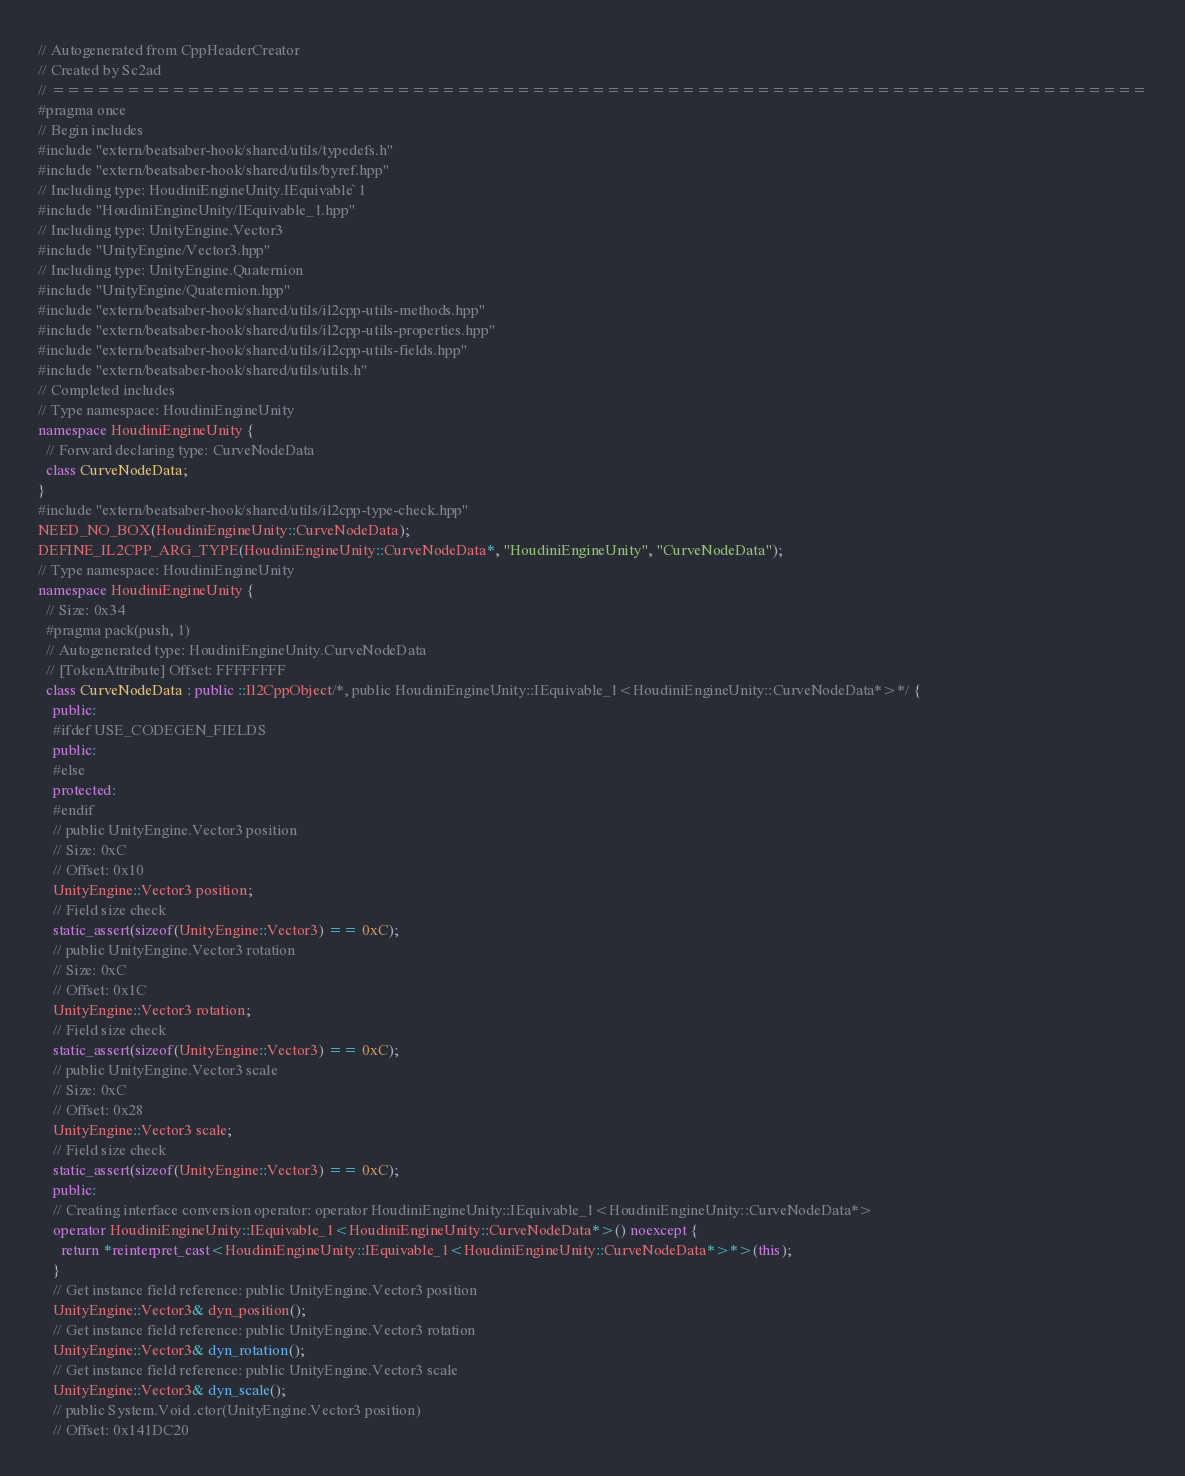Convert code to text. <code><loc_0><loc_0><loc_500><loc_500><_C++_>// Autogenerated from CppHeaderCreator
// Created by Sc2ad
// =========================================================================
#pragma once
// Begin includes
#include "extern/beatsaber-hook/shared/utils/typedefs.h"
#include "extern/beatsaber-hook/shared/utils/byref.hpp"
// Including type: HoudiniEngineUnity.IEquivable`1
#include "HoudiniEngineUnity/IEquivable_1.hpp"
// Including type: UnityEngine.Vector3
#include "UnityEngine/Vector3.hpp"
// Including type: UnityEngine.Quaternion
#include "UnityEngine/Quaternion.hpp"
#include "extern/beatsaber-hook/shared/utils/il2cpp-utils-methods.hpp"
#include "extern/beatsaber-hook/shared/utils/il2cpp-utils-properties.hpp"
#include "extern/beatsaber-hook/shared/utils/il2cpp-utils-fields.hpp"
#include "extern/beatsaber-hook/shared/utils/utils.h"
// Completed includes
// Type namespace: HoudiniEngineUnity
namespace HoudiniEngineUnity {
  // Forward declaring type: CurveNodeData
  class CurveNodeData;
}
#include "extern/beatsaber-hook/shared/utils/il2cpp-type-check.hpp"
NEED_NO_BOX(HoudiniEngineUnity::CurveNodeData);
DEFINE_IL2CPP_ARG_TYPE(HoudiniEngineUnity::CurveNodeData*, "HoudiniEngineUnity", "CurveNodeData");
// Type namespace: HoudiniEngineUnity
namespace HoudiniEngineUnity {
  // Size: 0x34
  #pragma pack(push, 1)
  // Autogenerated type: HoudiniEngineUnity.CurveNodeData
  // [TokenAttribute] Offset: FFFFFFFF
  class CurveNodeData : public ::Il2CppObject/*, public HoudiniEngineUnity::IEquivable_1<HoudiniEngineUnity::CurveNodeData*>*/ {
    public:
    #ifdef USE_CODEGEN_FIELDS
    public:
    #else
    protected:
    #endif
    // public UnityEngine.Vector3 position
    // Size: 0xC
    // Offset: 0x10
    UnityEngine::Vector3 position;
    // Field size check
    static_assert(sizeof(UnityEngine::Vector3) == 0xC);
    // public UnityEngine.Vector3 rotation
    // Size: 0xC
    // Offset: 0x1C
    UnityEngine::Vector3 rotation;
    // Field size check
    static_assert(sizeof(UnityEngine::Vector3) == 0xC);
    // public UnityEngine.Vector3 scale
    // Size: 0xC
    // Offset: 0x28
    UnityEngine::Vector3 scale;
    // Field size check
    static_assert(sizeof(UnityEngine::Vector3) == 0xC);
    public:
    // Creating interface conversion operator: operator HoudiniEngineUnity::IEquivable_1<HoudiniEngineUnity::CurveNodeData*>
    operator HoudiniEngineUnity::IEquivable_1<HoudiniEngineUnity::CurveNodeData*>() noexcept {
      return *reinterpret_cast<HoudiniEngineUnity::IEquivable_1<HoudiniEngineUnity::CurveNodeData*>*>(this);
    }
    // Get instance field reference: public UnityEngine.Vector3 position
    UnityEngine::Vector3& dyn_position();
    // Get instance field reference: public UnityEngine.Vector3 rotation
    UnityEngine::Vector3& dyn_rotation();
    // Get instance field reference: public UnityEngine.Vector3 scale
    UnityEngine::Vector3& dyn_scale();
    // public System.Void .ctor(UnityEngine.Vector3 position)
    // Offset: 0x141DC20</code> 